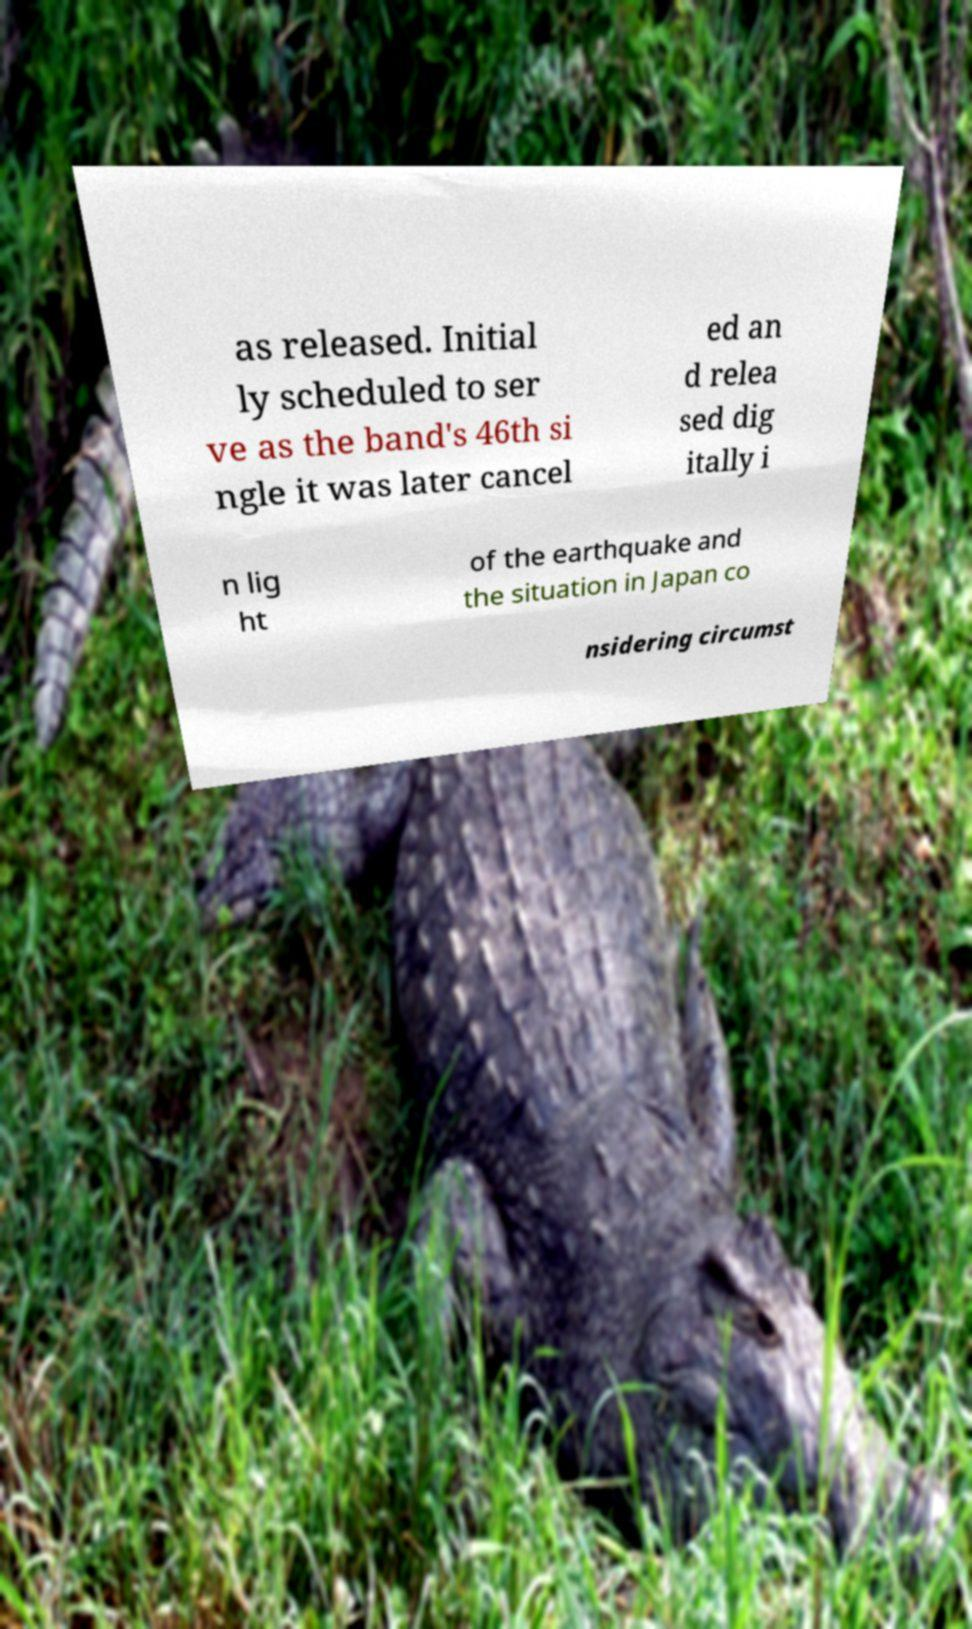There's text embedded in this image that I need extracted. Can you transcribe it verbatim? as released. Initial ly scheduled to ser ve as the band's 46th si ngle it was later cancel ed an d relea sed dig itally i n lig ht of the earthquake and the situation in Japan co nsidering circumst 